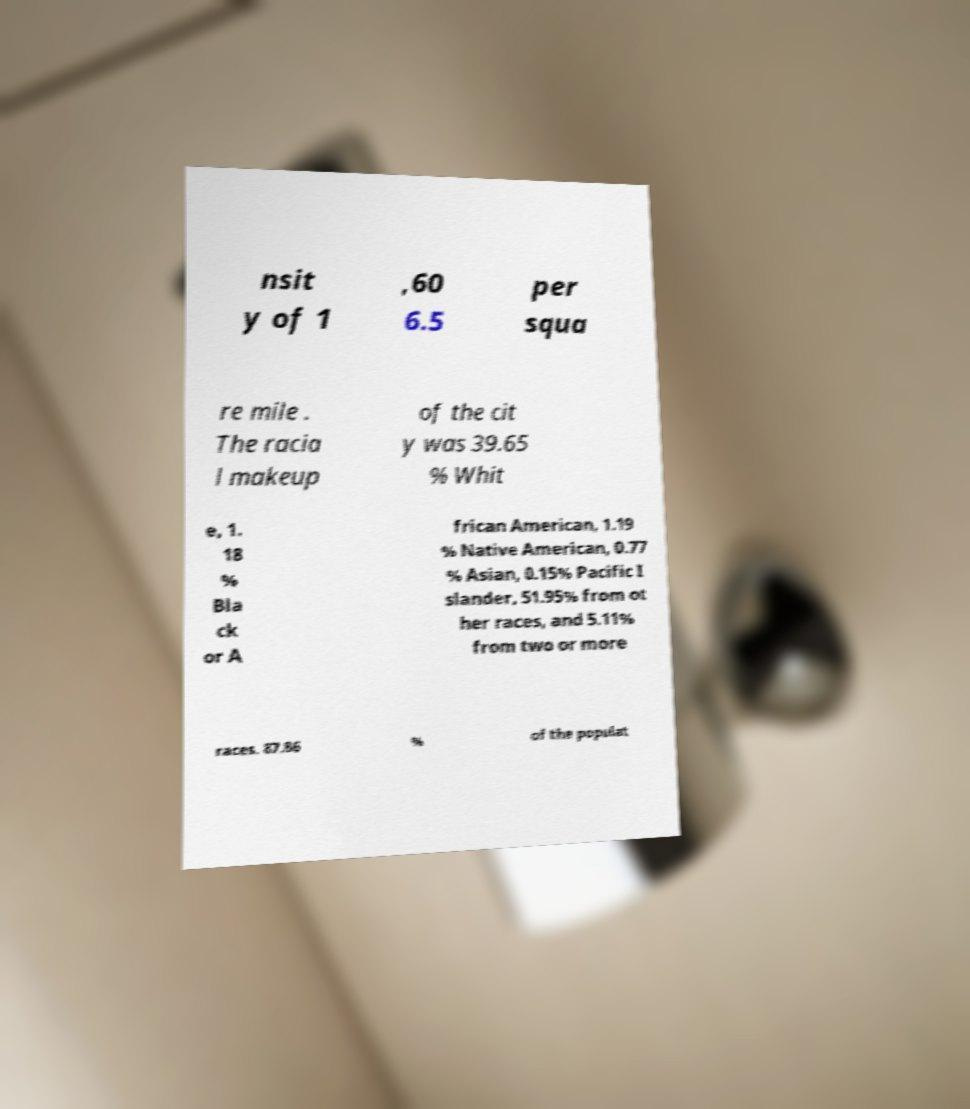I need the written content from this picture converted into text. Can you do that? nsit y of 1 ,60 6.5 per squa re mile . The racia l makeup of the cit y was 39.65 % Whit e, 1. 18 % Bla ck or A frican American, 1.19 % Native American, 0.77 % Asian, 0.15% Pacific I slander, 51.95% from ot her races, and 5.11% from two or more races. 87.86 % of the populat 